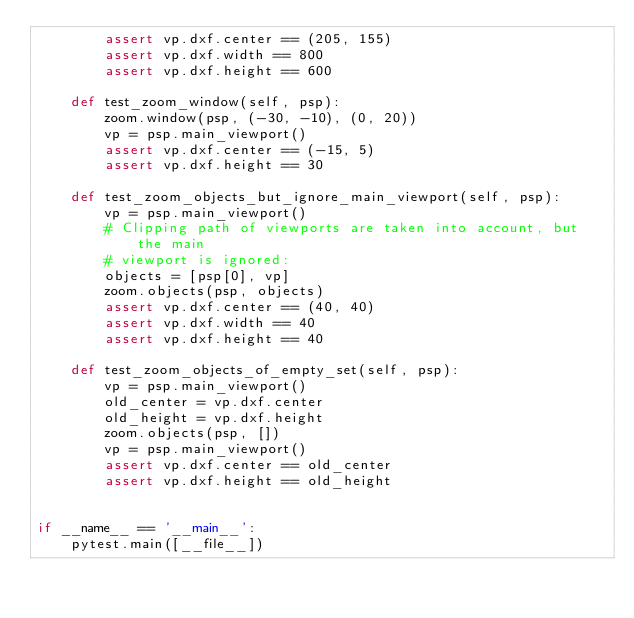Convert code to text. <code><loc_0><loc_0><loc_500><loc_500><_Python_>        assert vp.dxf.center == (205, 155)
        assert vp.dxf.width == 800
        assert vp.dxf.height == 600

    def test_zoom_window(self, psp):
        zoom.window(psp, (-30, -10), (0, 20))
        vp = psp.main_viewport()
        assert vp.dxf.center == (-15, 5)
        assert vp.dxf.height == 30

    def test_zoom_objects_but_ignore_main_viewport(self, psp):
        vp = psp.main_viewport()
        # Clipping path of viewports are taken into account, but the main
        # viewport is ignored:
        objects = [psp[0], vp]
        zoom.objects(psp, objects)
        assert vp.dxf.center == (40, 40)
        assert vp.dxf.width == 40
        assert vp.dxf.height == 40

    def test_zoom_objects_of_empty_set(self, psp):
        vp = psp.main_viewport()
        old_center = vp.dxf.center
        old_height = vp.dxf.height
        zoom.objects(psp, [])
        vp = psp.main_viewport()
        assert vp.dxf.center == old_center
        assert vp.dxf.height == old_height


if __name__ == '__main__':
    pytest.main([__file__])
</code> 